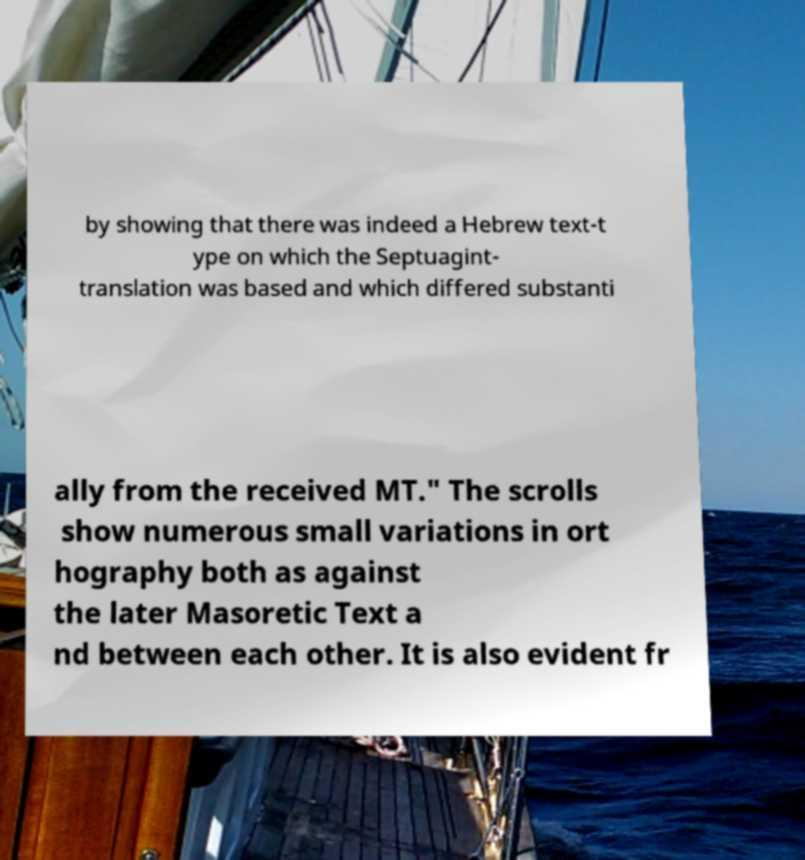I need the written content from this picture converted into text. Can you do that? by showing that there was indeed a Hebrew text-t ype on which the Septuagint- translation was based and which differed substanti ally from the received MT." The scrolls show numerous small variations in ort hography both as against the later Masoretic Text a nd between each other. It is also evident fr 